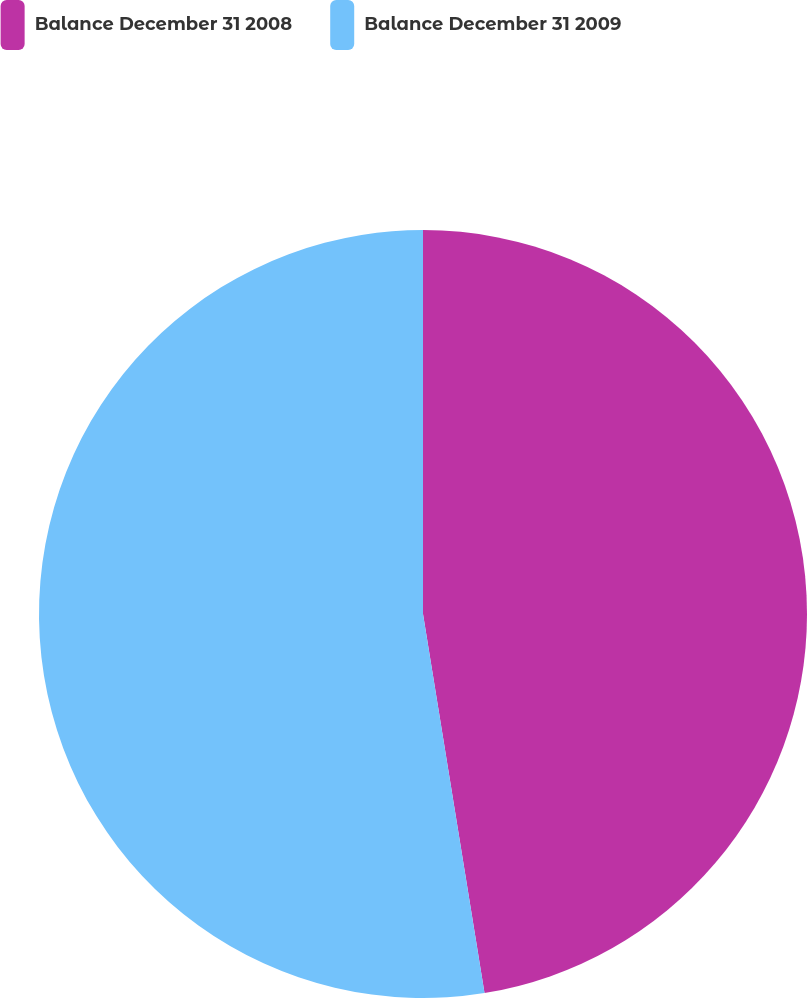Convert chart. <chart><loc_0><loc_0><loc_500><loc_500><pie_chart><fcel>Balance December 31 2008<fcel>Balance December 31 2009<nl><fcel>47.44%<fcel>52.56%<nl></chart> 